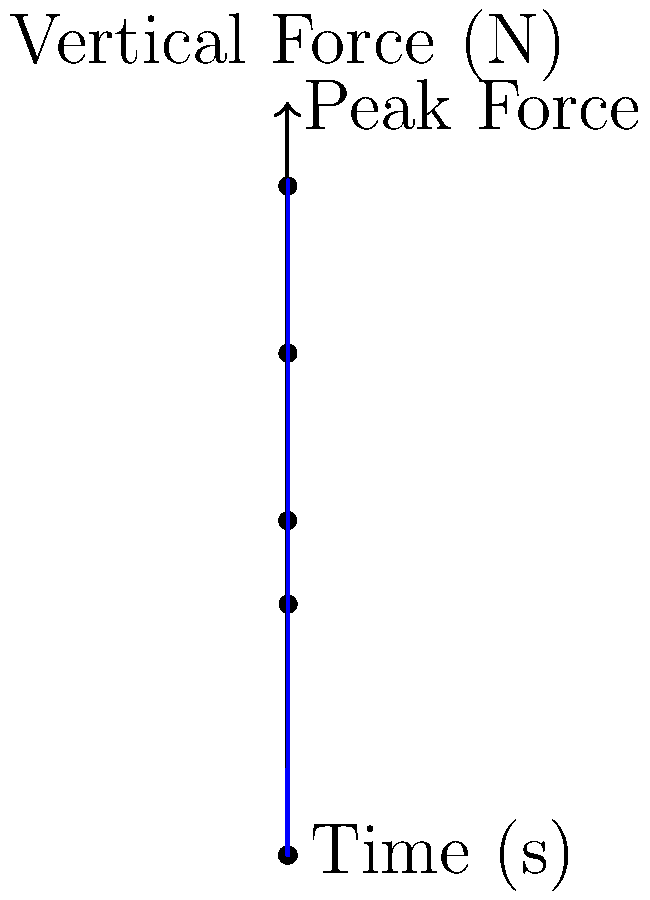Given the vertical ground reaction force data from a force plate during a single step of gait analysis, as shown in the graph, determine the impulse (in N·s) generated during the stance phase. Assume the stance phase occurs between t = 0 s and t = 1 s. To calculate the impulse during the stance phase, we need to follow these steps:

1) Impulse is defined as the integral of force over time: $$ I = \int_{t_1}^{t_2} F(t) dt $$

2) Since we have discrete data points, we can approximate this integral using the trapezoidal rule:

   $$ I \approx \sum_{i=1}^{n} \frac{1}{2}(F_i + F_{i-1})(t_i - t_{i-1}) $$

3) Let's calculate each trapezoid area:

   From 0 to 0.2 s: $\frac{1}{2}(0 + 400)(0.2 - 0) = 40$ N·s
   From 0.2 to 0.4 s: $\frac{1}{2}(400 + 800)(0.4 - 0.2) = 120$ N·s
   From 0.4 to 0.6 s: $\frac{1}{2}(800 + 600)(0.6 - 0.4) = 140$ N·s
   From 0.6 to 0.8 s: $\frac{1}{2}(600 + 300)(0.8 - 0.6) = 90$ N·s
   From 0.8 to 1.0 s: $\frac{1}{2}(300 + 0)(1.0 - 0.8) = 30$ N·s

4) Sum all these areas:

   $$ I = 40 + 120 + 140 + 90 + 30 = 420 \text{ N·s} $$

Therefore, the impulse during the stance phase is approximately 420 N·s.
Answer: 420 N·s 